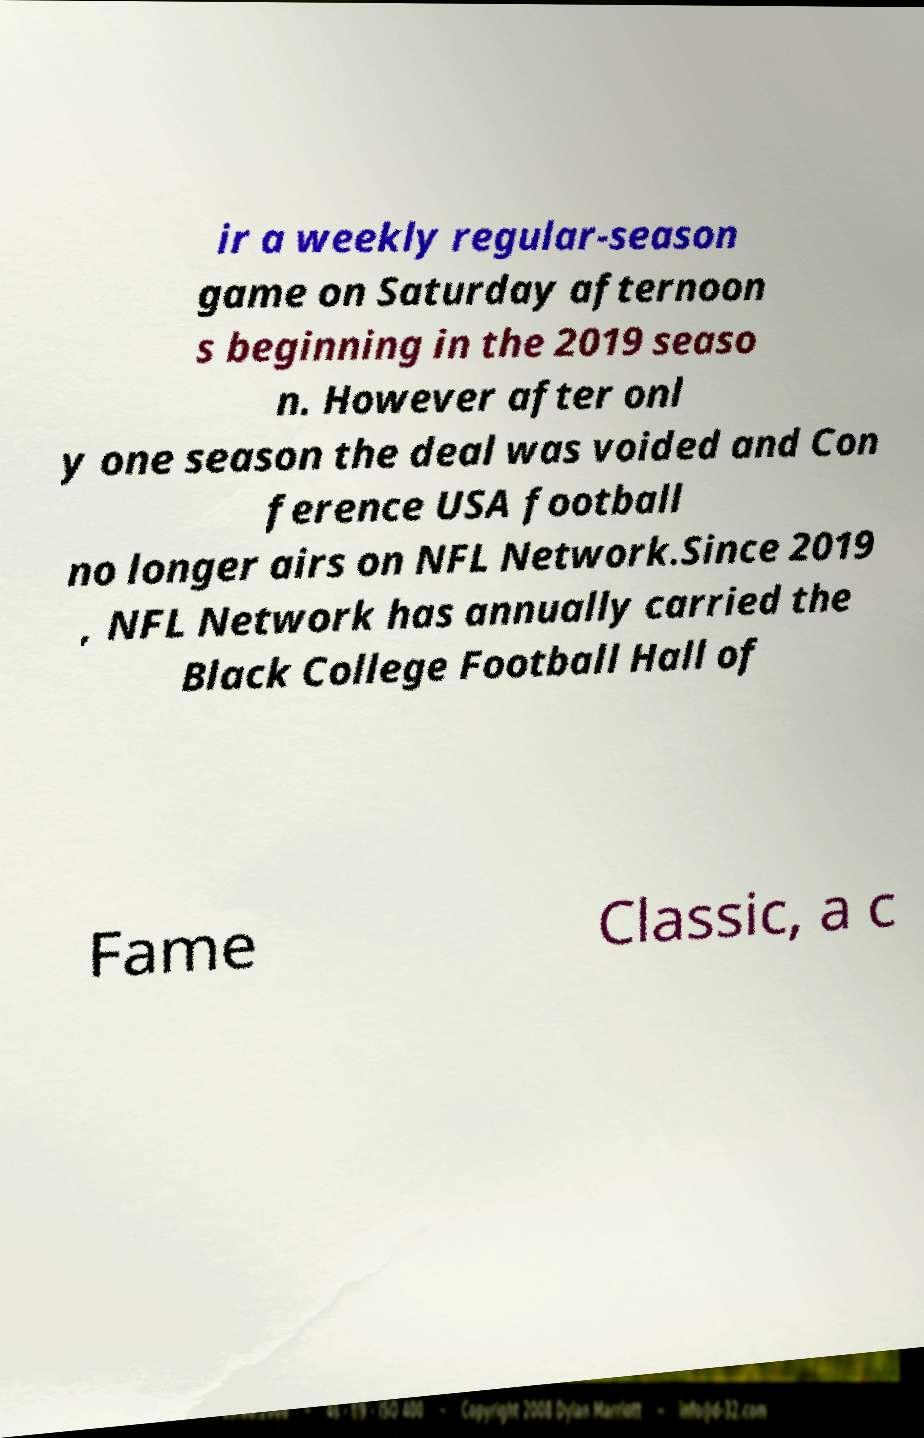Could you extract and type out the text from this image? ir a weekly regular-season game on Saturday afternoon s beginning in the 2019 seaso n. However after onl y one season the deal was voided and Con ference USA football no longer airs on NFL Network.Since 2019 , NFL Network has annually carried the Black College Football Hall of Fame Classic, a c 